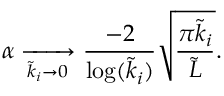<formula> <loc_0><loc_0><loc_500><loc_500>\alpha \xrightarrow [ \tilde { k } _ { i } \to 0 \frac { - 2 } { \log ( \tilde { k } _ { i } ) } \sqrt { \frac { \pi \tilde { k } _ { i } } { \tilde { L } } } .</formula> 